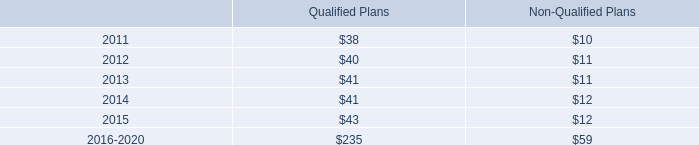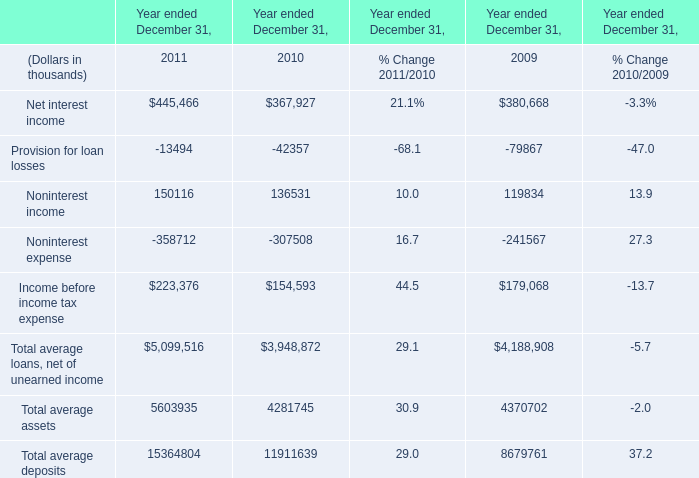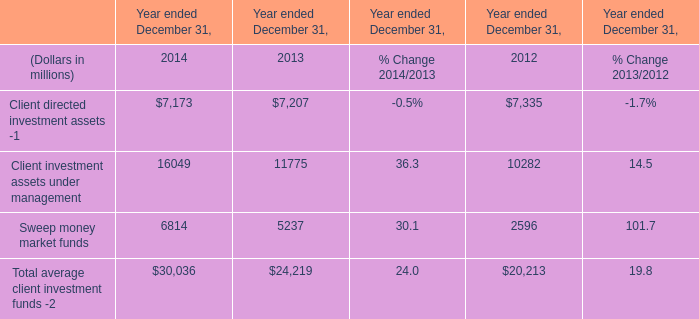at december 31 , 2010 what was the percent of the shares remaining authorization to repurchase of the amount authorization by the board in 2007 
Computations: (27 / 50)
Answer: 0.54. 